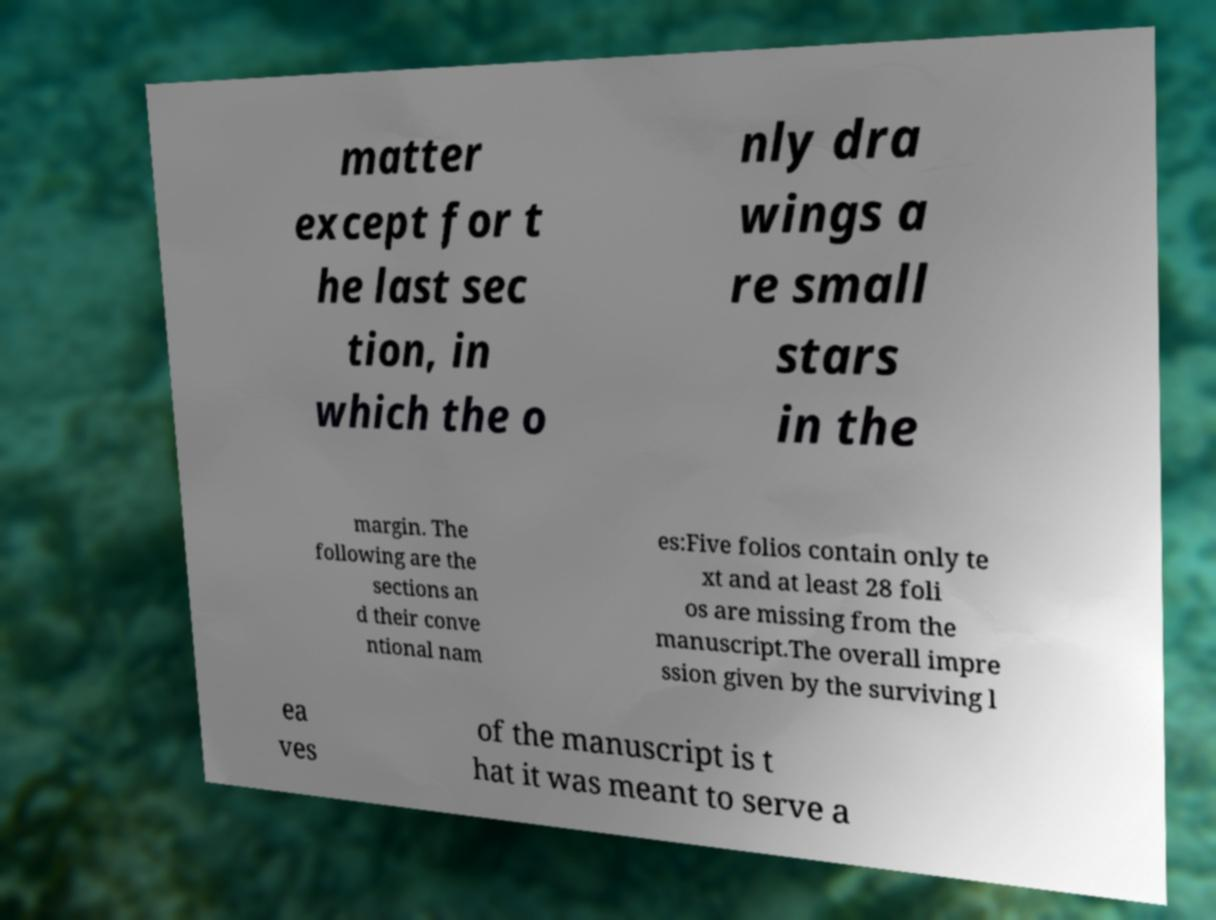Can you read and provide the text displayed in the image?This photo seems to have some interesting text. Can you extract and type it out for me? matter except for t he last sec tion, in which the o nly dra wings a re small stars in the margin. The following are the sections an d their conve ntional nam es:Five folios contain only te xt and at least 28 foli os are missing from the manuscript.The overall impre ssion given by the surviving l ea ves of the manuscript is t hat it was meant to serve a 